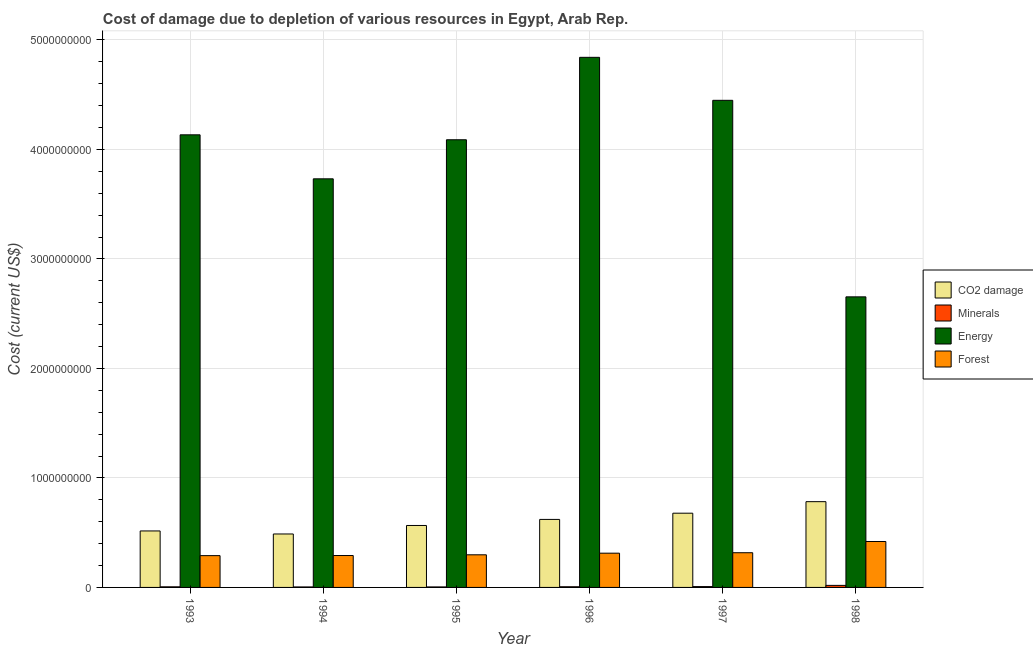Are the number of bars per tick equal to the number of legend labels?
Provide a short and direct response. Yes. Are the number of bars on each tick of the X-axis equal?
Offer a terse response. Yes. How many bars are there on the 1st tick from the left?
Provide a succinct answer. 4. How many bars are there on the 1st tick from the right?
Offer a very short reply. 4. What is the label of the 2nd group of bars from the left?
Give a very brief answer. 1994. What is the cost of damage due to depletion of energy in 1996?
Give a very brief answer. 4.84e+09. Across all years, what is the maximum cost of damage due to depletion of coal?
Ensure brevity in your answer.  7.83e+08. Across all years, what is the minimum cost of damage due to depletion of coal?
Make the answer very short. 4.88e+08. In which year was the cost of damage due to depletion of coal maximum?
Make the answer very short. 1998. In which year was the cost of damage due to depletion of forests minimum?
Give a very brief answer. 1993. What is the total cost of damage due to depletion of coal in the graph?
Provide a short and direct response. 3.65e+09. What is the difference between the cost of damage due to depletion of energy in 1997 and that in 1998?
Offer a terse response. 1.79e+09. What is the difference between the cost of damage due to depletion of coal in 1993 and the cost of damage due to depletion of energy in 1997?
Provide a succinct answer. -1.62e+08. What is the average cost of damage due to depletion of forests per year?
Your response must be concise. 3.21e+08. In the year 1994, what is the difference between the cost of damage due to depletion of coal and cost of damage due to depletion of minerals?
Ensure brevity in your answer.  0. What is the ratio of the cost of damage due to depletion of energy in 1995 to that in 1996?
Give a very brief answer. 0.84. What is the difference between the highest and the second highest cost of damage due to depletion of energy?
Make the answer very short. 3.93e+08. What is the difference between the highest and the lowest cost of damage due to depletion of energy?
Make the answer very short. 2.19e+09. Is the sum of the cost of damage due to depletion of coal in 1996 and 1998 greater than the maximum cost of damage due to depletion of energy across all years?
Provide a succinct answer. Yes. What does the 3rd bar from the left in 1994 represents?
Your response must be concise. Energy. What does the 3rd bar from the right in 1998 represents?
Your response must be concise. Minerals. Are all the bars in the graph horizontal?
Your response must be concise. No. How many years are there in the graph?
Ensure brevity in your answer.  6. What is the difference between two consecutive major ticks on the Y-axis?
Offer a terse response. 1.00e+09. Are the values on the major ticks of Y-axis written in scientific E-notation?
Your answer should be very brief. No. Does the graph contain any zero values?
Your answer should be very brief. No. How many legend labels are there?
Provide a succinct answer. 4. How are the legend labels stacked?
Provide a succinct answer. Vertical. What is the title of the graph?
Your answer should be very brief. Cost of damage due to depletion of various resources in Egypt, Arab Rep. . Does "Quality of public administration" appear as one of the legend labels in the graph?
Ensure brevity in your answer.  No. What is the label or title of the X-axis?
Make the answer very short. Year. What is the label or title of the Y-axis?
Provide a succinct answer. Cost (current US$). What is the Cost (current US$) of CO2 damage in 1993?
Offer a terse response. 5.16e+08. What is the Cost (current US$) of Minerals in 1993?
Your response must be concise. 5.47e+06. What is the Cost (current US$) of Energy in 1993?
Give a very brief answer. 4.13e+09. What is the Cost (current US$) in Forest in 1993?
Your answer should be compact. 2.90e+08. What is the Cost (current US$) of CO2 damage in 1994?
Offer a terse response. 4.88e+08. What is the Cost (current US$) in Minerals in 1994?
Ensure brevity in your answer.  4.45e+06. What is the Cost (current US$) in Energy in 1994?
Make the answer very short. 3.73e+09. What is the Cost (current US$) in Forest in 1994?
Your answer should be very brief. 2.91e+08. What is the Cost (current US$) of CO2 damage in 1995?
Offer a very short reply. 5.66e+08. What is the Cost (current US$) of Minerals in 1995?
Keep it short and to the point. 4.58e+06. What is the Cost (current US$) of Energy in 1995?
Your answer should be very brief. 4.09e+09. What is the Cost (current US$) of Forest in 1995?
Ensure brevity in your answer.  2.98e+08. What is the Cost (current US$) in CO2 damage in 1996?
Provide a short and direct response. 6.21e+08. What is the Cost (current US$) in Minerals in 1996?
Provide a succinct answer. 6.05e+06. What is the Cost (current US$) of Energy in 1996?
Your response must be concise. 4.84e+09. What is the Cost (current US$) of Forest in 1996?
Make the answer very short. 3.13e+08. What is the Cost (current US$) in CO2 damage in 1997?
Ensure brevity in your answer.  6.78e+08. What is the Cost (current US$) in Minerals in 1997?
Provide a succinct answer. 7.71e+06. What is the Cost (current US$) in Energy in 1997?
Your answer should be compact. 4.45e+09. What is the Cost (current US$) of Forest in 1997?
Provide a succinct answer. 3.17e+08. What is the Cost (current US$) of CO2 damage in 1998?
Your answer should be compact. 7.83e+08. What is the Cost (current US$) of Minerals in 1998?
Provide a succinct answer. 1.87e+07. What is the Cost (current US$) in Energy in 1998?
Your answer should be compact. 2.65e+09. What is the Cost (current US$) of Forest in 1998?
Offer a very short reply. 4.19e+08. Across all years, what is the maximum Cost (current US$) in CO2 damage?
Your answer should be compact. 7.83e+08. Across all years, what is the maximum Cost (current US$) of Minerals?
Your answer should be compact. 1.87e+07. Across all years, what is the maximum Cost (current US$) of Energy?
Provide a succinct answer. 4.84e+09. Across all years, what is the maximum Cost (current US$) in Forest?
Your answer should be compact. 4.19e+08. Across all years, what is the minimum Cost (current US$) in CO2 damage?
Make the answer very short. 4.88e+08. Across all years, what is the minimum Cost (current US$) of Minerals?
Your answer should be very brief. 4.45e+06. Across all years, what is the minimum Cost (current US$) of Energy?
Offer a terse response. 2.65e+09. Across all years, what is the minimum Cost (current US$) of Forest?
Provide a succinct answer. 2.90e+08. What is the total Cost (current US$) of CO2 damage in the graph?
Provide a short and direct response. 3.65e+09. What is the total Cost (current US$) of Minerals in the graph?
Your answer should be compact. 4.70e+07. What is the total Cost (current US$) of Energy in the graph?
Your answer should be very brief. 2.39e+1. What is the total Cost (current US$) in Forest in the graph?
Ensure brevity in your answer.  1.93e+09. What is the difference between the Cost (current US$) of CO2 damage in 1993 and that in 1994?
Offer a very short reply. 2.77e+07. What is the difference between the Cost (current US$) of Minerals in 1993 and that in 1994?
Your answer should be compact. 1.02e+06. What is the difference between the Cost (current US$) of Energy in 1993 and that in 1994?
Give a very brief answer. 4.02e+08. What is the difference between the Cost (current US$) in Forest in 1993 and that in 1994?
Your answer should be very brief. -1.07e+06. What is the difference between the Cost (current US$) in CO2 damage in 1993 and that in 1995?
Make the answer very short. -4.98e+07. What is the difference between the Cost (current US$) of Minerals in 1993 and that in 1995?
Make the answer very short. 8.95e+05. What is the difference between the Cost (current US$) in Energy in 1993 and that in 1995?
Provide a short and direct response. 4.52e+07. What is the difference between the Cost (current US$) in Forest in 1993 and that in 1995?
Your answer should be very brief. -7.53e+06. What is the difference between the Cost (current US$) of CO2 damage in 1993 and that in 1996?
Provide a succinct answer. -1.05e+08. What is the difference between the Cost (current US$) in Minerals in 1993 and that in 1996?
Offer a terse response. -5.85e+05. What is the difference between the Cost (current US$) in Energy in 1993 and that in 1996?
Make the answer very short. -7.08e+08. What is the difference between the Cost (current US$) of Forest in 1993 and that in 1996?
Your response must be concise. -2.25e+07. What is the difference between the Cost (current US$) in CO2 damage in 1993 and that in 1997?
Offer a very short reply. -1.62e+08. What is the difference between the Cost (current US$) of Minerals in 1993 and that in 1997?
Give a very brief answer. -2.24e+06. What is the difference between the Cost (current US$) in Energy in 1993 and that in 1997?
Keep it short and to the point. -3.15e+08. What is the difference between the Cost (current US$) of Forest in 1993 and that in 1997?
Your answer should be very brief. -2.66e+07. What is the difference between the Cost (current US$) in CO2 damage in 1993 and that in 1998?
Provide a short and direct response. -2.67e+08. What is the difference between the Cost (current US$) in Minerals in 1993 and that in 1998?
Your answer should be compact. -1.32e+07. What is the difference between the Cost (current US$) in Energy in 1993 and that in 1998?
Keep it short and to the point. 1.48e+09. What is the difference between the Cost (current US$) in Forest in 1993 and that in 1998?
Your answer should be compact. -1.29e+08. What is the difference between the Cost (current US$) of CO2 damage in 1994 and that in 1995?
Ensure brevity in your answer.  -7.76e+07. What is the difference between the Cost (current US$) of Minerals in 1994 and that in 1995?
Your answer should be compact. -1.24e+05. What is the difference between the Cost (current US$) of Energy in 1994 and that in 1995?
Give a very brief answer. -3.57e+08. What is the difference between the Cost (current US$) of Forest in 1994 and that in 1995?
Your answer should be very brief. -6.46e+06. What is the difference between the Cost (current US$) of CO2 damage in 1994 and that in 1996?
Your answer should be compact. -1.33e+08. What is the difference between the Cost (current US$) of Minerals in 1994 and that in 1996?
Your answer should be very brief. -1.60e+06. What is the difference between the Cost (current US$) in Energy in 1994 and that in 1996?
Give a very brief answer. -1.11e+09. What is the difference between the Cost (current US$) of Forest in 1994 and that in 1996?
Make the answer very short. -2.14e+07. What is the difference between the Cost (current US$) in CO2 damage in 1994 and that in 1997?
Make the answer very short. -1.90e+08. What is the difference between the Cost (current US$) in Minerals in 1994 and that in 1997?
Offer a very short reply. -3.26e+06. What is the difference between the Cost (current US$) of Energy in 1994 and that in 1997?
Your response must be concise. -7.17e+08. What is the difference between the Cost (current US$) in Forest in 1994 and that in 1997?
Keep it short and to the point. -2.56e+07. What is the difference between the Cost (current US$) in CO2 damage in 1994 and that in 1998?
Give a very brief answer. -2.95e+08. What is the difference between the Cost (current US$) in Minerals in 1994 and that in 1998?
Your answer should be very brief. -1.43e+07. What is the difference between the Cost (current US$) in Energy in 1994 and that in 1998?
Your answer should be very brief. 1.08e+09. What is the difference between the Cost (current US$) of Forest in 1994 and that in 1998?
Provide a succinct answer. -1.28e+08. What is the difference between the Cost (current US$) of CO2 damage in 1995 and that in 1996?
Ensure brevity in your answer.  -5.55e+07. What is the difference between the Cost (current US$) of Minerals in 1995 and that in 1996?
Make the answer very short. -1.48e+06. What is the difference between the Cost (current US$) of Energy in 1995 and that in 1996?
Offer a terse response. -7.53e+08. What is the difference between the Cost (current US$) of Forest in 1995 and that in 1996?
Offer a terse response. -1.50e+07. What is the difference between the Cost (current US$) in CO2 damage in 1995 and that in 1997?
Make the answer very short. -1.12e+08. What is the difference between the Cost (current US$) in Minerals in 1995 and that in 1997?
Keep it short and to the point. -3.13e+06. What is the difference between the Cost (current US$) in Energy in 1995 and that in 1997?
Give a very brief answer. -3.60e+08. What is the difference between the Cost (current US$) of Forest in 1995 and that in 1997?
Provide a succinct answer. -1.91e+07. What is the difference between the Cost (current US$) of CO2 damage in 1995 and that in 1998?
Offer a very short reply. -2.18e+08. What is the difference between the Cost (current US$) of Minerals in 1995 and that in 1998?
Provide a succinct answer. -1.41e+07. What is the difference between the Cost (current US$) of Energy in 1995 and that in 1998?
Make the answer very short. 1.43e+09. What is the difference between the Cost (current US$) of Forest in 1995 and that in 1998?
Make the answer very short. -1.22e+08. What is the difference between the Cost (current US$) in CO2 damage in 1996 and that in 1997?
Your answer should be compact. -5.67e+07. What is the difference between the Cost (current US$) in Minerals in 1996 and that in 1997?
Your answer should be compact. -1.65e+06. What is the difference between the Cost (current US$) of Energy in 1996 and that in 1997?
Ensure brevity in your answer.  3.93e+08. What is the difference between the Cost (current US$) of Forest in 1996 and that in 1997?
Your response must be concise. -4.15e+06. What is the difference between the Cost (current US$) of CO2 damage in 1996 and that in 1998?
Make the answer very short. -1.62e+08. What is the difference between the Cost (current US$) of Minerals in 1996 and that in 1998?
Your response must be concise. -1.27e+07. What is the difference between the Cost (current US$) of Energy in 1996 and that in 1998?
Offer a terse response. 2.19e+09. What is the difference between the Cost (current US$) in Forest in 1996 and that in 1998?
Provide a short and direct response. -1.07e+08. What is the difference between the Cost (current US$) in CO2 damage in 1997 and that in 1998?
Your response must be concise. -1.05e+08. What is the difference between the Cost (current US$) of Minerals in 1997 and that in 1998?
Offer a terse response. -1.10e+07. What is the difference between the Cost (current US$) of Energy in 1997 and that in 1998?
Your answer should be compact. 1.79e+09. What is the difference between the Cost (current US$) of Forest in 1997 and that in 1998?
Offer a terse response. -1.02e+08. What is the difference between the Cost (current US$) in CO2 damage in 1993 and the Cost (current US$) in Minerals in 1994?
Ensure brevity in your answer.  5.11e+08. What is the difference between the Cost (current US$) in CO2 damage in 1993 and the Cost (current US$) in Energy in 1994?
Make the answer very short. -3.22e+09. What is the difference between the Cost (current US$) of CO2 damage in 1993 and the Cost (current US$) of Forest in 1994?
Your answer should be very brief. 2.24e+08. What is the difference between the Cost (current US$) of Minerals in 1993 and the Cost (current US$) of Energy in 1994?
Provide a succinct answer. -3.73e+09. What is the difference between the Cost (current US$) in Minerals in 1993 and the Cost (current US$) in Forest in 1994?
Your answer should be compact. -2.86e+08. What is the difference between the Cost (current US$) in Energy in 1993 and the Cost (current US$) in Forest in 1994?
Make the answer very short. 3.84e+09. What is the difference between the Cost (current US$) in CO2 damage in 1993 and the Cost (current US$) in Minerals in 1995?
Give a very brief answer. 5.11e+08. What is the difference between the Cost (current US$) of CO2 damage in 1993 and the Cost (current US$) of Energy in 1995?
Keep it short and to the point. -3.57e+09. What is the difference between the Cost (current US$) in CO2 damage in 1993 and the Cost (current US$) in Forest in 1995?
Provide a short and direct response. 2.18e+08. What is the difference between the Cost (current US$) of Minerals in 1993 and the Cost (current US$) of Energy in 1995?
Ensure brevity in your answer.  -4.08e+09. What is the difference between the Cost (current US$) in Minerals in 1993 and the Cost (current US$) in Forest in 1995?
Your answer should be compact. -2.92e+08. What is the difference between the Cost (current US$) in Energy in 1993 and the Cost (current US$) in Forest in 1995?
Make the answer very short. 3.84e+09. What is the difference between the Cost (current US$) of CO2 damage in 1993 and the Cost (current US$) of Minerals in 1996?
Ensure brevity in your answer.  5.10e+08. What is the difference between the Cost (current US$) of CO2 damage in 1993 and the Cost (current US$) of Energy in 1996?
Your answer should be compact. -4.33e+09. What is the difference between the Cost (current US$) in CO2 damage in 1993 and the Cost (current US$) in Forest in 1996?
Make the answer very short. 2.03e+08. What is the difference between the Cost (current US$) in Minerals in 1993 and the Cost (current US$) in Energy in 1996?
Give a very brief answer. -4.84e+09. What is the difference between the Cost (current US$) of Minerals in 1993 and the Cost (current US$) of Forest in 1996?
Your answer should be compact. -3.07e+08. What is the difference between the Cost (current US$) in Energy in 1993 and the Cost (current US$) in Forest in 1996?
Your answer should be very brief. 3.82e+09. What is the difference between the Cost (current US$) of CO2 damage in 1993 and the Cost (current US$) of Minerals in 1997?
Offer a very short reply. 5.08e+08. What is the difference between the Cost (current US$) in CO2 damage in 1993 and the Cost (current US$) in Energy in 1997?
Provide a succinct answer. -3.93e+09. What is the difference between the Cost (current US$) of CO2 damage in 1993 and the Cost (current US$) of Forest in 1997?
Provide a succinct answer. 1.99e+08. What is the difference between the Cost (current US$) in Minerals in 1993 and the Cost (current US$) in Energy in 1997?
Offer a very short reply. -4.44e+09. What is the difference between the Cost (current US$) of Minerals in 1993 and the Cost (current US$) of Forest in 1997?
Keep it short and to the point. -3.11e+08. What is the difference between the Cost (current US$) of Energy in 1993 and the Cost (current US$) of Forest in 1997?
Make the answer very short. 3.82e+09. What is the difference between the Cost (current US$) in CO2 damage in 1993 and the Cost (current US$) in Minerals in 1998?
Offer a terse response. 4.97e+08. What is the difference between the Cost (current US$) in CO2 damage in 1993 and the Cost (current US$) in Energy in 1998?
Make the answer very short. -2.14e+09. What is the difference between the Cost (current US$) in CO2 damage in 1993 and the Cost (current US$) in Forest in 1998?
Provide a short and direct response. 9.64e+07. What is the difference between the Cost (current US$) in Minerals in 1993 and the Cost (current US$) in Energy in 1998?
Keep it short and to the point. -2.65e+09. What is the difference between the Cost (current US$) of Minerals in 1993 and the Cost (current US$) of Forest in 1998?
Provide a short and direct response. -4.14e+08. What is the difference between the Cost (current US$) of Energy in 1993 and the Cost (current US$) of Forest in 1998?
Offer a very short reply. 3.71e+09. What is the difference between the Cost (current US$) of CO2 damage in 1994 and the Cost (current US$) of Minerals in 1995?
Your answer should be very brief. 4.84e+08. What is the difference between the Cost (current US$) in CO2 damage in 1994 and the Cost (current US$) in Energy in 1995?
Your response must be concise. -3.60e+09. What is the difference between the Cost (current US$) of CO2 damage in 1994 and the Cost (current US$) of Forest in 1995?
Offer a terse response. 1.90e+08. What is the difference between the Cost (current US$) of Minerals in 1994 and the Cost (current US$) of Energy in 1995?
Offer a very short reply. -4.08e+09. What is the difference between the Cost (current US$) of Minerals in 1994 and the Cost (current US$) of Forest in 1995?
Offer a very short reply. -2.93e+08. What is the difference between the Cost (current US$) of Energy in 1994 and the Cost (current US$) of Forest in 1995?
Your response must be concise. 3.43e+09. What is the difference between the Cost (current US$) in CO2 damage in 1994 and the Cost (current US$) in Minerals in 1996?
Give a very brief answer. 4.82e+08. What is the difference between the Cost (current US$) in CO2 damage in 1994 and the Cost (current US$) in Energy in 1996?
Give a very brief answer. -4.35e+09. What is the difference between the Cost (current US$) of CO2 damage in 1994 and the Cost (current US$) of Forest in 1996?
Ensure brevity in your answer.  1.75e+08. What is the difference between the Cost (current US$) of Minerals in 1994 and the Cost (current US$) of Energy in 1996?
Offer a very short reply. -4.84e+09. What is the difference between the Cost (current US$) of Minerals in 1994 and the Cost (current US$) of Forest in 1996?
Give a very brief answer. -3.08e+08. What is the difference between the Cost (current US$) in Energy in 1994 and the Cost (current US$) in Forest in 1996?
Give a very brief answer. 3.42e+09. What is the difference between the Cost (current US$) of CO2 damage in 1994 and the Cost (current US$) of Minerals in 1997?
Offer a terse response. 4.80e+08. What is the difference between the Cost (current US$) in CO2 damage in 1994 and the Cost (current US$) in Energy in 1997?
Give a very brief answer. -3.96e+09. What is the difference between the Cost (current US$) of CO2 damage in 1994 and the Cost (current US$) of Forest in 1997?
Keep it short and to the point. 1.71e+08. What is the difference between the Cost (current US$) in Minerals in 1994 and the Cost (current US$) in Energy in 1997?
Keep it short and to the point. -4.44e+09. What is the difference between the Cost (current US$) in Minerals in 1994 and the Cost (current US$) in Forest in 1997?
Ensure brevity in your answer.  -3.13e+08. What is the difference between the Cost (current US$) in Energy in 1994 and the Cost (current US$) in Forest in 1997?
Offer a terse response. 3.41e+09. What is the difference between the Cost (current US$) in CO2 damage in 1994 and the Cost (current US$) in Minerals in 1998?
Your answer should be compact. 4.69e+08. What is the difference between the Cost (current US$) in CO2 damage in 1994 and the Cost (current US$) in Energy in 1998?
Offer a very short reply. -2.17e+09. What is the difference between the Cost (current US$) of CO2 damage in 1994 and the Cost (current US$) of Forest in 1998?
Ensure brevity in your answer.  6.87e+07. What is the difference between the Cost (current US$) of Minerals in 1994 and the Cost (current US$) of Energy in 1998?
Provide a short and direct response. -2.65e+09. What is the difference between the Cost (current US$) in Minerals in 1994 and the Cost (current US$) in Forest in 1998?
Your answer should be very brief. -4.15e+08. What is the difference between the Cost (current US$) of Energy in 1994 and the Cost (current US$) of Forest in 1998?
Make the answer very short. 3.31e+09. What is the difference between the Cost (current US$) in CO2 damage in 1995 and the Cost (current US$) in Minerals in 1996?
Keep it short and to the point. 5.60e+08. What is the difference between the Cost (current US$) of CO2 damage in 1995 and the Cost (current US$) of Energy in 1996?
Keep it short and to the point. -4.28e+09. What is the difference between the Cost (current US$) in CO2 damage in 1995 and the Cost (current US$) in Forest in 1996?
Your answer should be compact. 2.53e+08. What is the difference between the Cost (current US$) of Minerals in 1995 and the Cost (current US$) of Energy in 1996?
Give a very brief answer. -4.84e+09. What is the difference between the Cost (current US$) in Minerals in 1995 and the Cost (current US$) in Forest in 1996?
Your answer should be very brief. -3.08e+08. What is the difference between the Cost (current US$) of Energy in 1995 and the Cost (current US$) of Forest in 1996?
Provide a succinct answer. 3.78e+09. What is the difference between the Cost (current US$) in CO2 damage in 1995 and the Cost (current US$) in Minerals in 1997?
Your response must be concise. 5.58e+08. What is the difference between the Cost (current US$) in CO2 damage in 1995 and the Cost (current US$) in Energy in 1997?
Your answer should be compact. -3.88e+09. What is the difference between the Cost (current US$) of CO2 damage in 1995 and the Cost (current US$) of Forest in 1997?
Offer a terse response. 2.49e+08. What is the difference between the Cost (current US$) of Minerals in 1995 and the Cost (current US$) of Energy in 1997?
Give a very brief answer. -4.44e+09. What is the difference between the Cost (current US$) in Minerals in 1995 and the Cost (current US$) in Forest in 1997?
Your response must be concise. -3.12e+08. What is the difference between the Cost (current US$) of Energy in 1995 and the Cost (current US$) of Forest in 1997?
Provide a succinct answer. 3.77e+09. What is the difference between the Cost (current US$) of CO2 damage in 1995 and the Cost (current US$) of Minerals in 1998?
Give a very brief answer. 5.47e+08. What is the difference between the Cost (current US$) of CO2 damage in 1995 and the Cost (current US$) of Energy in 1998?
Your answer should be very brief. -2.09e+09. What is the difference between the Cost (current US$) in CO2 damage in 1995 and the Cost (current US$) in Forest in 1998?
Offer a terse response. 1.46e+08. What is the difference between the Cost (current US$) of Minerals in 1995 and the Cost (current US$) of Energy in 1998?
Your answer should be very brief. -2.65e+09. What is the difference between the Cost (current US$) in Minerals in 1995 and the Cost (current US$) in Forest in 1998?
Your response must be concise. -4.15e+08. What is the difference between the Cost (current US$) in Energy in 1995 and the Cost (current US$) in Forest in 1998?
Provide a succinct answer. 3.67e+09. What is the difference between the Cost (current US$) in CO2 damage in 1996 and the Cost (current US$) in Minerals in 1997?
Provide a succinct answer. 6.13e+08. What is the difference between the Cost (current US$) of CO2 damage in 1996 and the Cost (current US$) of Energy in 1997?
Your answer should be very brief. -3.83e+09. What is the difference between the Cost (current US$) of CO2 damage in 1996 and the Cost (current US$) of Forest in 1997?
Provide a succinct answer. 3.04e+08. What is the difference between the Cost (current US$) of Minerals in 1996 and the Cost (current US$) of Energy in 1997?
Ensure brevity in your answer.  -4.44e+09. What is the difference between the Cost (current US$) in Minerals in 1996 and the Cost (current US$) in Forest in 1997?
Keep it short and to the point. -3.11e+08. What is the difference between the Cost (current US$) of Energy in 1996 and the Cost (current US$) of Forest in 1997?
Your answer should be compact. 4.52e+09. What is the difference between the Cost (current US$) of CO2 damage in 1996 and the Cost (current US$) of Minerals in 1998?
Provide a succinct answer. 6.02e+08. What is the difference between the Cost (current US$) of CO2 damage in 1996 and the Cost (current US$) of Energy in 1998?
Make the answer very short. -2.03e+09. What is the difference between the Cost (current US$) in CO2 damage in 1996 and the Cost (current US$) in Forest in 1998?
Your response must be concise. 2.02e+08. What is the difference between the Cost (current US$) in Minerals in 1996 and the Cost (current US$) in Energy in 1998?
Provide a short and direct response. -2.65e+09. What is the difference between the Cost (current US$) of Minerals in 1996 and the Cost (current US$) of Forest in 1998?
Offer a terse response. -4.13e+08. What is the difference between the Cost (current US$) in Energy in 1996 and the Cost (current US$) in Forest in 1998?
Offer a very short reply. 4.42e+09. What is the difference between the Cost (current US$) of CO2 damage in 1997 and the Cost (current US$) of Minerals in 1998?
Make the answer very short. 6.59e+08. What is the difference between the Cost (current US$) in CO2 damage in 1997 and the Cost (current US$) in Energy in 1998?
Keep it short and to the point. -1.98e+09. What is the difference between the Cost (current US$) of CO2 damage in 1997 and the Cost (current US$) of Forest in 1998?
Your answer should be compact. 2.58e+08. What is the difference between the Cost (current US$) of Minerals in 1997 and the Cost (current US$) of Energy in 1998?
Offer a very short reply. -2.65e+09. What is the difference between the Cost (current US$) in Minerals in 1997 and the Cost (current US$) in Forest in 1998?
Provide a succinct answer. -4.12e+08. What is the difference between the Cost (current US$) in Energy in 1997 and the Cost (current US$) in Forest in 1998?
Your answer should be very brief. 4.03e+09. What is the average Cost (current US$) of CO2 damage per year?
Ensure brevity in your answer.  6.09e+08. What is the average Cost (current US$) in Minerals per year?
Keep it short and to the point. 7.83e+06. What is the average Cost (current US$) in Energy per year?
Your answer should be compact. 3.98e+09. What is the average Cost (current US$) of Forest per year?
Your answer should be very brief. 3.21e+08. In the year 1993, what is the difference between the Cost (current US$) in CO2 damage and Cost (current US$) in Minerals?
Make the answer very short. 5.10e+08. In the year 1993, what is the difference between the Cost (current US$) of CO2 damage and Cost (current US$) of Energy?
Offer a very short reply. -3.62e+09. In the year 1993, what is the difference between the Cost (current US$) in CO2 damage and Cost (current US$) in Forest?
Ensure brevity in your answer.  2.26e+08. In the year 1993, what is the difference between the Cost (current US$) of Minerals and Cost (current US$) of Energy?
Your answer should be compact. -4.13e+09. In the year 1993, what is the difference between the Cost (current US$) in Minerals and Cost (current US$) in Forest?
Offer a terse response. -2.85e+08. In the year 1993, what is the difference between the Cost (current US$) in Energy and Cost (current US$) in Forest?
Provide a short and direct response. 3.84e+09. In the year 1994, what is the difference between the Cost (current US$) in CO2 damage and Cost (current US$) in Minerals?
Give a very brief answer. 4.84e+08. In the year 1994, what is the difference between the Cost (current US$) in CO2 damage and Cost (current US$) in Energy?
Offer a very short reply. -3.24e+09. In the year 1994, what is the difference between the Cost (current US$) of CO2 damage and Cost (current US$) of Forest?
Your response must be concise. 1.97e+08. In the year 1994, what is the difference between the Cost (current US$) of Minerals and Cost (current US$) of Energy?
Give a very brief answer. -3.73e+09. In the year 1994, what is the difference between the Cost (current US$) of Minerals and Cost (current US$) of Forest?
Your response must be concise. -2.87e+08. In the year 1994, what is the difference between the Cost (current US$) in Energy and Cost (current US$) in Forest?
Provide a succinct answer. 3.44e+09. In the year 1995, what is the difference between the Cost (current US$) of CO2 damage and Cost (current US$) of Minerals?
Your answer should be compact. 5.61e+08. In the year 1995, what is the difference between the Cost (current US$) in CO2 damage and Cost (current US$) in Energy?
Give a very brief answer. -3.52e+09. In the year 1995, what is the difference between the Cost (current US$) of CO2 damage and Cost (current US$) of Forest?
Provide a succinct answer. 2.68e+08. In the year 1995, what is the difference between the Cost (current US$) of Minerals and Cost (current US$) of Energy?
Offer a very short reply. -4.08e+09. In the year 1995, what is the difference between the Cost (current US$) in Minerals and Cost (current US$) in Forest?
Offer a very short reply. -2.93e+08. In the year 1995, what is the difference between the Cost (current US$) in Energy and Cost (current US$) in Forest?
Offer a terse response. 3.79e+09. In the year 1996, what is the difference between the Cost (current US$) in CO2 damage and Cost (current US$) in Minerals?
Give a very brief answer. 6.15e+08. In the year 1996, what is the difference between the Cost (current US$) of CO2 damage and Cost (current US$) of Energy?
Provide a short and direct response. -4.22e+09. In the year 1996, what is the difference between the Cost (current US$) in CO2 damage and Cost (current US$) in Forest?
Give a very brief answer. 3.08e+08. In the year 1996, what is the difference between the Cost (current US$) of Minerals and Cost (current US$) of Energy?
Offer a very short reply. -4.83e+09. In the year 1996, what is the difference between the Cost (current US$) in Minerals and Cost (current US$) in Forest?
Your response must be concise. -3.07e+08. In the year 1996, what is the difference between the Cost (current US$) in Energy and Cost (current US$) in Forest?
Provide a short and direct response. 4.53e+09. In the year 1997, what is the difference between the Cost (current US$) in CO2 damage and Cost (current US$) in Minerals?
Make the answer very short. 6.70e+08. In the year 1997, what is the difference between the Cost (current US$) in CO2 damage and Cost (current US$) in Energy?
Provide a succinct answer. -3.77e+09. In the year 1997, what is the difference between the Cost (current US$) in CO2 damage and Cost (current US$) in Forest?
Offer a very short reply. 3.61e+08. In the year 1997, what is the difference between the Cost (current US$) of Minerals and Cost (current US$) of Energy?
Ensure brevity in your answer.  -4.44e+09. In the year 1997, what is the difference between the Cost (current US$) in Minerals and Cost (current US$) in Forest?
Provide a succinct answer. -3.09e+08. In the year 1997, what is the difference between the Cost (current US$) of Energy and Cost (current US$) of Forest?
Ensure brevity in your answer.  4.13e+09. In the year 1998, what is the difference between the Cost (current US$) in CO2 damage and Cost (current US$) in Minerals?
Provide a short and direct response. 7.65e+08. In the year 1998, what is the difference between the Cost (current US$) of CO2 damage and Cost (current US$) of Energy?
Keep it short and to the point. -1.87e+09. In the year 1998, what is the difference between the Cost (current US$) in CO2 damage and Cost (current US$) in Forest?
Provide a succinct answer. 3.64e+08. In the year 1998, what is the difference between the Cost (current US$) in Minerals and Cost (current US$) in Energy?
Make the answer very short. -2.63e+09. In the year 1998, what is the difference between the Cost (current US$) of Minerals and Cost (current US$) of Forest?
Give a very brief answer. -4.01e+08. In the year 1998, what is the difference between the Cost (current US$) in Energy and Cost (current US$) in Forest?
Make the answer very short. 2.23e+09. What is the ratio of the Cost (current US$) of CO2 damage in 1993 to that in 1994?
Give a very brief answer. 1.06. What is the ratio of the Cost (current US$) of Minerals in 1993 to that in 1994?
Keep it short and to the point. 1.23. What is the ratio of the Cost (current US$) of Energy in 1993 to that in 1994?
Keep it short and to the point. 1.11. What is the ratio of the Cost (current US$) of CO2 damage in 1993 to that in 1995?
Keep it short and to the point. 0.91. What is the ratio of the Cost (current US$) of Minerals in 1993 to that in 1995?
Offer a terse response. 1.2. What is the ratio of the Cost (current US$) in Forest in 1993 to that in 1995?
Ensure brevity in your answer.  0.97. What is the ratio of the Cost (current US$) in CO2 damage in 1993 to that in 1996?
Make the answer very short. 0.83. What is the ratio of the Cost (current US$) of Minerals in 1993 to that in 1996?
Ensure brevity in your answer.  0.9. What is the ratio of the Cost (current US$) of Energy in 1993 to that in 1996?
Your answer should be compact. 0.85. What is the ratio of the Cost (current US$) in Forest in 1993 to that in 1996?
Your response must be concise. 0.93. What is the ratio of the Cost (current US$) in CO2 damage in 1993 to that in 1997?
Make the answer very short. 0.76. What is the ratio of the Cost (current US$) of Minerals in 1993 to that in 1997?
Give a very brief answer. 0.71. What is the ratio of the Cost (current US$) in Energy in 1993 to that in 1997?
Give a very brief answer. 0.93. What is the ratio of the Cost (current US$) of Forest in 1993 to that in 1997?
Your answer should be compact. 0.92. What is the ratio of the Cost (current US$) of CO2 damage in 1993 to that in 1998?
Keep it short and to the point. 0.66. What is the ratio of the Cost (current US$) in Minerals in 1993 to that in 1998?
Offer a terse response. 0.29. What is the ratio of the Cost (current US$) in Energy in 1993 to that in 1998?
Give a very brief answer. 1.56. What is the ratio of the Cost (current US$) of Forest in 1993 to that in 1998?
Your answer should be compact. 0.69. What is the ratio of the Cost (current US$) of CO2 damage in 1994 to that in 1995?
Provide a short and direct response. 0.86. What is the ratio of the Cost (current US$) in Minerals in 1994 to that in 1995?
Keep it short and to the point. 0.97. What is the ratio of the Cost (current US$) in Energy in 1994 to that in 1995?
Provide a succinct answer. 0.91. What is the ratio of the Cost (current US$) of Forest in 1994 to that in 1995?
Ensure brevity in your answer.  0.98. What is the ratio of the Cost (current US$) in CO2 damage in 1994 to that in 1996?
Offer a terse response. 0.79. What is the ratio of the Cost (current US$) of Minerals in 1994 to that in 1996?
Your response must be concise. 0.74. What is the ratio of the Cost (current US$) of Energy in 1994 to that in 1996?
Provide a short and direct response. 0.77. What is the ratio of the Cost (current US$) of Forest in 1994 to that in 1996?
Offer a terse response. 0.93. What is the ratio of the Cost (current US$) in CO2 damage in 1994 to that in 1997?
Ensure brevity in your answer.  0.72. What is the ratio of the Cost (current US$) of Minerals in 1994 to that in 1997?
Offer a terse response. 0.58. What is the ratio of the Cost (current US$) in Energy in 1994 to that in 1997?
Give a very brief answer. 0.84. What is the ratio of the Cost (current US$) in Forest in 1994 to that in 1997?
Provide a succinct answer. 0.92. What is the ratio of the Cost (current US$) in CO2 damage in 1994 to that in 1998?
Your answer should be very brief. 0.62. What is the ratio of the Cost (current US$) of Minerals in 1994 to that in 1998?
Provide a succinct answer. 0.24. What is the ratio of the Cost (current US$) in Energy in 1994 to that in 1998?
Offer a terse response. 1.41. What is the ratio of the Cost (current US$) in Forest in 1994 to that in 1998?
Ensure brevity in your answer.  0.69. What is the ratio of the Cost (current US$) in CO2 damage in 1995 to that in 1996?
Your answer should be very brief. 0.91. What is the ratio of the Cost (current US$) in Minerals in 1995 to that in 1996?
Make the answer very short. 0.76. What is the ratio of the Cost (current US$) in Energy in 1995 to that in 1996?
Keep it short and to the point. 0.84. What is the ratio of the Cost (current US$) in Forest in 1995 to that in 1996?
Provide a short and direct response. 0.95. What is the ratio of the Cost (current US$) of CO2 damage in 1995 to that in 1997?
Ensure brevity in your answer.  0.83. What is the ratio of the Cost (current US$) of Minerals in 1995 to that in 1997?
Keep it short and to the point. 0.59. What is the ratio of the Cost (current US$) of Energy in 1995 to that in 1997?
Offer a very short reply. 0.92. What is the ratio of the Cost (current US$) in Forest in 1995 to that in 1997?
Provide a short and direct response. 0.94. What is the ratio of the Cost (current US$) of CO2 damage in 1995 to that in 1998?
Give a very brief answer. 0.72. What is the ratio of the Cost (current US$) of Minerals in 1995 to that in 1998?
Provide a short and direct response. 0.24. What is the ratio of the Cost (current US$) in Energy in 1995 to that in 1998?
Ensure brevity in your answer.  1.54. What is the ratio of the Cost (current US$) in Forest in 1995 to that in 1998?
Your response must be concise. 0.71. What is the ratio of the Cost (current US$) in CO2 damage in 1996 to that in 1997?
Your response must be concise. 0.92. What is the ratio of the Cost (current US$) in Minerals in 1996 to that in 1997?
Give a very brief answer. 0.79. What is the ratio of the Cost (current US$) in Energy in 1996 to that in 1997?
Give a very brief answer. 1.09. What is the ratio of the Cost (current US$) in Forest in 1996 to that in 1997?
Offer a very short reply. 0.99. What is the ratio of the Cost (current US$) in CO2 damage in 1996 to that in 1998?
Offer a terse response. 0.79. What is the ratio of the Cost (current US$) of Minerals in 1996 to that in 1998?
Offer a very short reply. 0.32. What is the ratio of the Cost (current US$) of Energy in 1996 to that in 1998?
Your answer should be compact. 1.82. What is the ratio of the Cost (current US$) in Forest in 1996 to that in 1998?
Offer a very short reply. 0.75. What is the ratio of the Cost (current US$) in CO2 damage in 1997 to that in 1998?
Provide a succinct answer. 0.87. What is the ratio of the Cost (current US$) in Minerals in 1997 to that in 1998?
Give a very brief answer. 0.41. What is the ratio of the Cost (current US$) of Energy in 1997 to that in 1998?
Give a very brief answer. 1.68. What is the ratio of the Cost (current US$) of Forest in 1997 to that in 1998?
Ensure brevity in your answer.  0.76. What is the difference between the highest and the second highest Cost (current US$) in CO2 damage?
Provide a short and direct response. 1.05e+08. What is the difference between the highest and the second highest Cost (current US$) of Minerals?
Your answer should be compact. 1.10e+07. What is the difference between the highest and the second highest Cost (current US$) of Energy?
Provide a succinct answer. 3.93e+08. What is the difference between the highest and the second highest Cost (current US$) of Forest?
Offer a terse response. 1.02e+08. What is the difference between the highest and the lowest Cost (current US$) in CO2 damage?
Provide a succinct answer. 2.95e+08. What is the difference between the highest and the lowest Cost (current US$) of Minerals?
Give a very brief answer. 1.43e+07. What is the difference between the highest and the lowest Cost (current US$) of Energy?
Offer a terse response. 2.19e+09. What is the difference between the highest and the lowest Cost (current US$) in Forest?
Ensure brevity in your answer.  1.29e+08. 